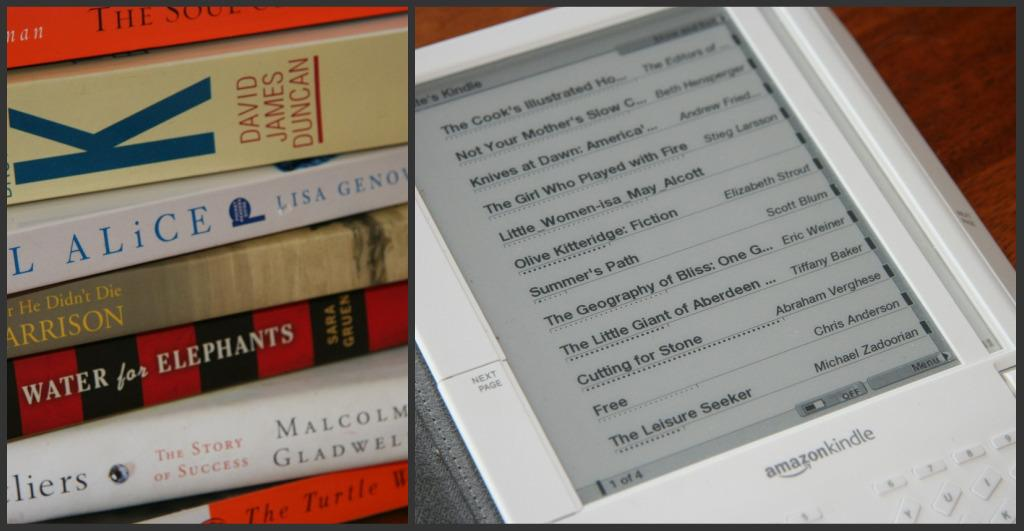<image>
Describe the image concisely. An Amazon Kindle displays a collection of books to read. 